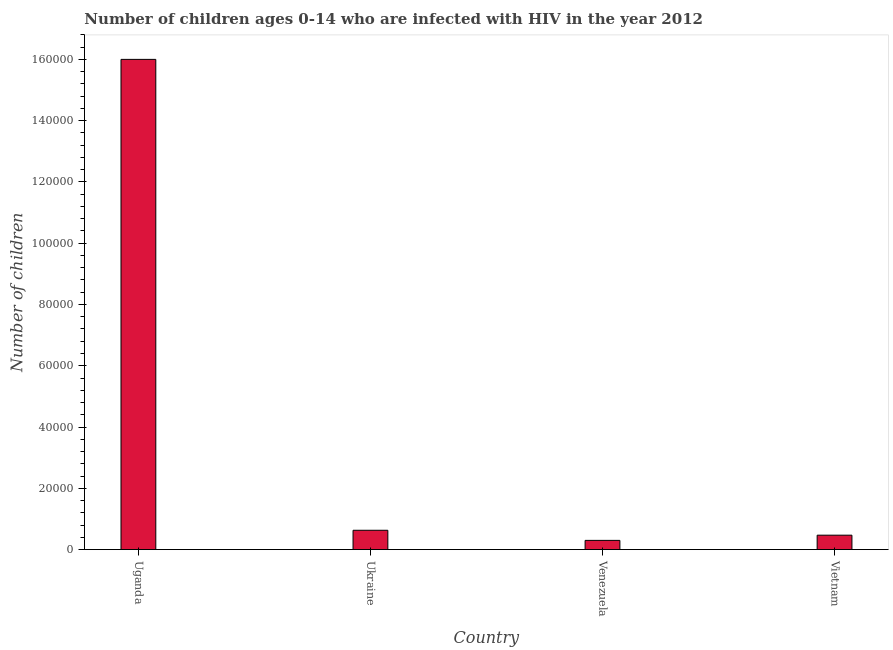Does the graph contain grids?
Provide a short and direct response. No. What is the title of the graph?
Offer a terse response. Number of children ages 0-14 who are infected with HIV in the year 2012. What is the label or title of the Y-axis?
Your response must be concise. Number of children. What is the number of children living with hiv in Uganda?
Provide a succinct answer. 1.60e+05. Across all countries, what is the maximum number of children living with hiv?
Provide a succinct answer. 1.60e+05. Across all countries, what is the minimum number of children living with hiv?
Provide a succinct answer. 3000. In which country was the number of children living with hiv maximum?
Provide a succinct answer. Uganda. In which country was the number of children living with hiv minimum?
Offer a very short reply. Venezuela. What is the sum of the number of children living with hiv?
Your answer should be compact. 1.74e+05. What is the difference between the number of children living with hiv in Uganda and Vietnam?
Your answer should be very brief. 1.55e+05. What is the average number of children living with hiv per country?
Your response must be concise. 4.35e+04. What is the median number of children living with hiv?
Keep it short and to the point. 5500. What is the ratio of the number of children living with hiv in Ukraine to that in Venezuela?
Provide a short and direct response. 2.1. What is the difference between the highest and the second highest number of children living with hiv?
Your answer should be compact. 1.54e+05. Is the sum of the number of children living with hiv in Venezuela and Vietnam greater than the maximum number of children living with hiv across all countries?
Your response must be concise. No. What is the difference between the highest and the lowest number of children living with hiv?
Make the answer very short. 1.57e+05. In how many countries, is the number of children living with hiv greater than the average number of children living with hiv taken over all countries?
Provide a short and direct response. 1. How many bars are there?
Give a very brief answer. 4. Are all the bars in the graph horizontal?
Offer a terse response. No. Are the values on the major ticks of Y-axis written in scientific E-notation?
Your answer should be very brief. No. What is the Number of children of Uganda?
Keep it short and to the point. 1.60e+05. What is the Number of children in Ukraine?
Keep it short and to the point. 6300. What is the Number of children of Venezuela?
Make the answer very short. 3000. What is the Number of children in Vietnam?
Offer a very short reply. 4700. What is the difference between the Number of children in Uganda and Ukraine?
Your answer should be compact. 1.54e+05. What is the difference between the Number of children in Uganda and Venezuela?
Offer a very short reply. 1.57e+05. What is the difference between the Number of children in Uganda and Vietnam?
Give a very brief answer. 1.55e+05. What is the difference between the Number of children in Ukraine and Venezuela?
Give a very brief answer. 3300. What is the difference between the Number of children in Ukraine and Vietnam?
Offer a very short reply. 1600. What is the difference between the Number of children in Venezuela and Vietnam?
Your answer should be compact. -1700. What is the ratio of the Number of children in Uganda to that in Ukraine?
Offer a terse response. 25.4. What is the ratio of the Number of children in Uganda to that in Venezuela?
Keep it short and to the point. 53.33. What is the ratio of the Number of children in Uganda to that in Vietnam?
Your response must be concise. 34.04. What is the ratio of the Number of children in Ukraine to that in Vietnam?
Provide a short and direct response. 1.34. What is the ratio of the Number of children in Venezuela to that in Vietnam?
Give a very brief answer. 0.64. 